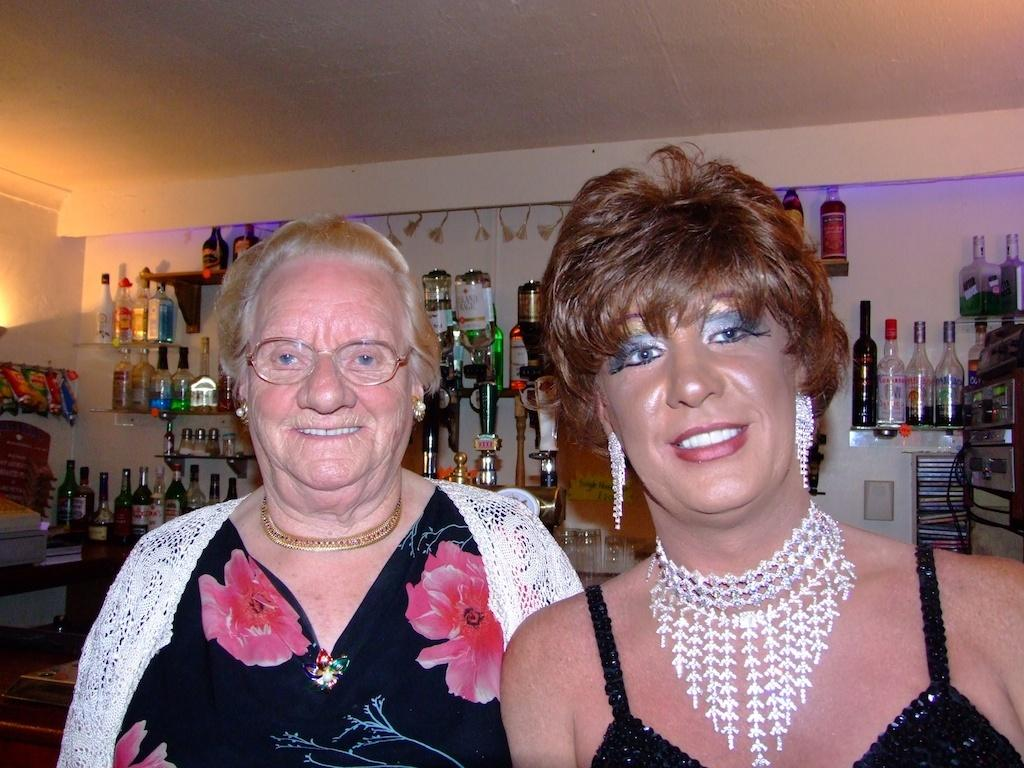How many people are in the image? There are two persons in the image. What can be seen in the background of the image? There is a wall, bottles, and a light in the background of the image. What type of cent can be seen crawling on the wall in the image? There is no cent, whether it be a coin or an insect, present in the image. 